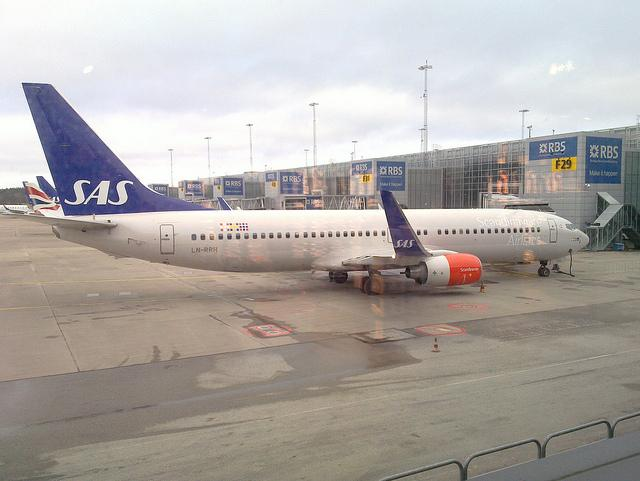What country is served by this airline? Please explain your reasoning. sweden. There are scandinavian flags on the side of the airplane's fuselage. 